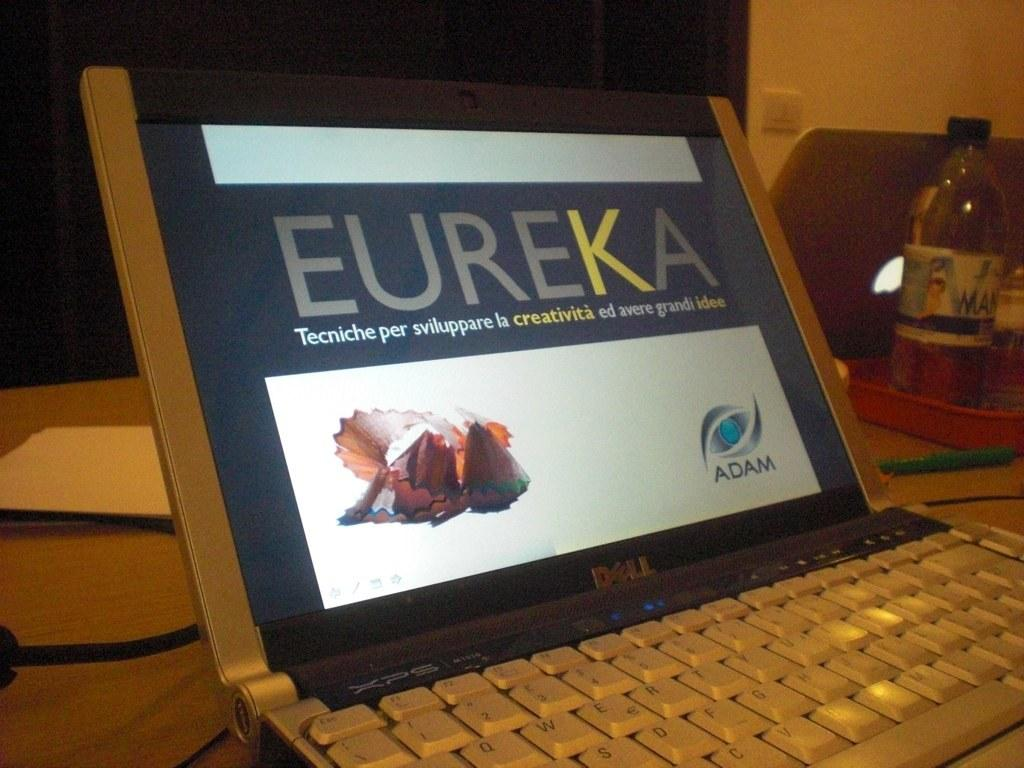<image>
Present a compact description of the photo's key features. A laptop with the word "Eureka" on the screen. 